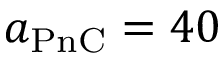Convert formula to latex. <formula><loc_0><loc_0><loc_500><loc_500>a _ { P n C } = 4 0</formula> 